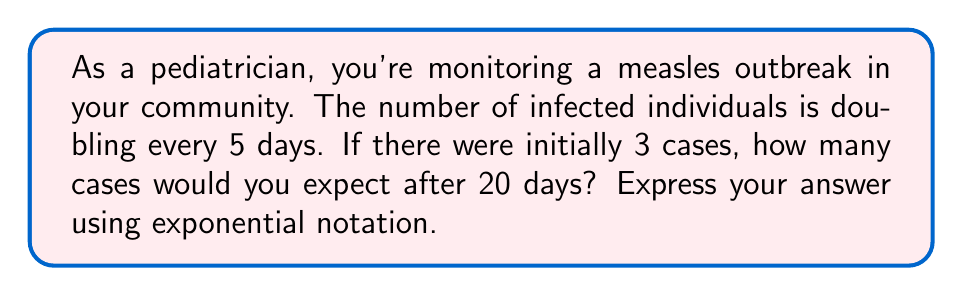Solve this math problem. Let's approach this step-by-step:

1) First, we need to identify the key components of exponential growth:
   - Initial number of cases: $N_0 = 3$
   - Time period: $t = 20$ days
   - Doubling time: $d = 5$ days

2) The number of doublings that occur in 20 days:
   $\text{Number of doublings} = \frac{t}{d} = \frac{20}{5} = 4$

3) In exponential growth, we can express this as:
   $N = N_0 \cdot 2^n$
   Where $N$ is the final number of cases, $N_0$ is the initial number, and $n$ is the number of doublings.

4) Substituting our values:
   $N = 3 \cdot 2^4$

5) Calculate:
   $N = 3 \cdot 16 = 48$

Therefore, after 20 days, you would expect 48 cases.

6) To express this in exponential notation as requested:
   $48 = 3 \cdot 2^4$

This form directly shows the initial number of cases (3) and the number of doublings that occurred (4).
Answer: $3 \cdot 2^4$ cases 